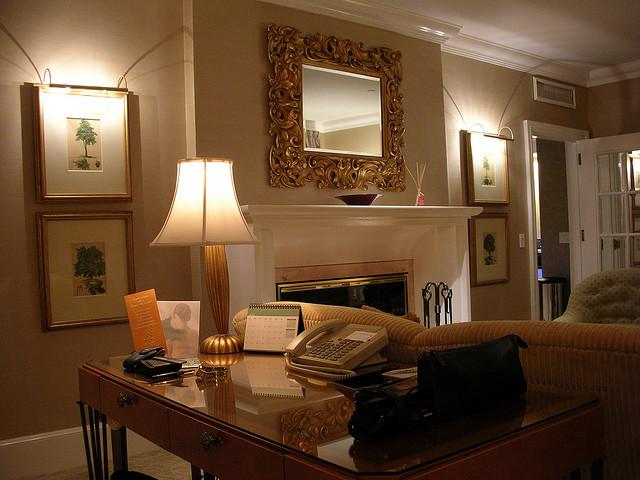Is this a living room?
Write a very short answer. Yes. Can this be evening?
Short answer required. Yes. What are on?
Keep it brief. Lights. 